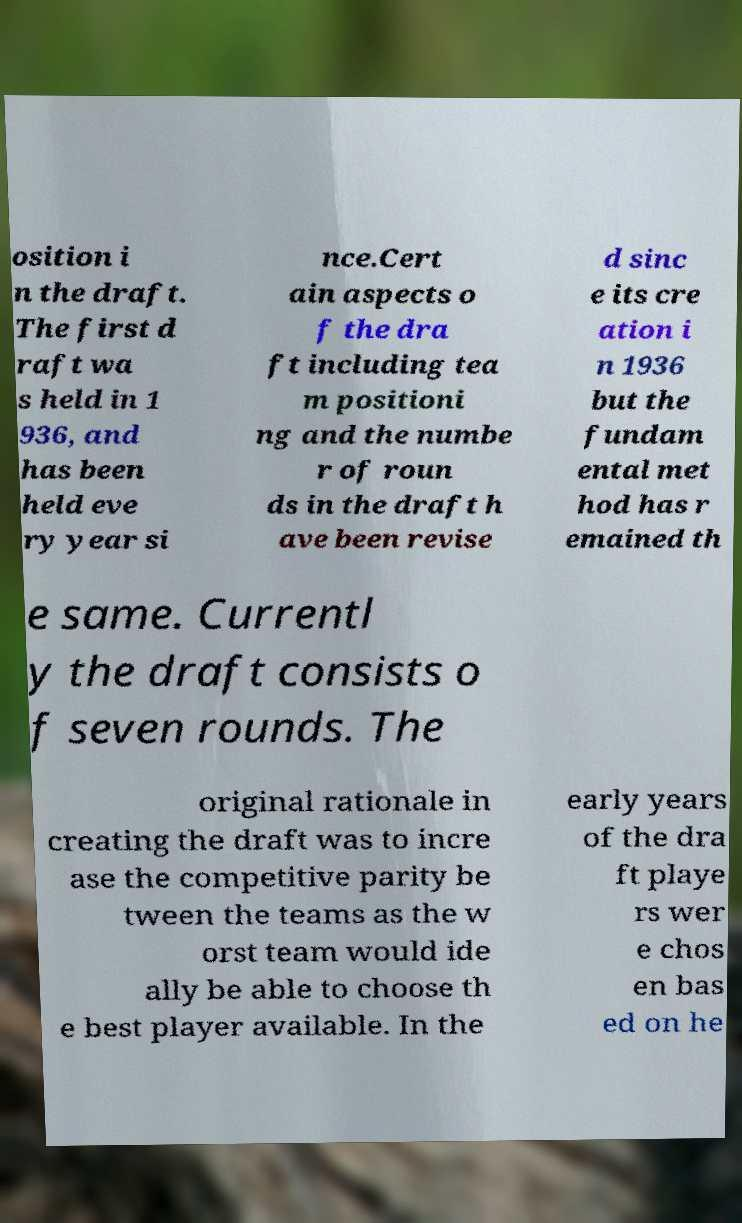Can you read and provide the text displayed in the image?This photo seems to have some interesting text. Can you extract and type it out for me? osition i n the draft. The first d raft wa s held in 1 936, and has been held eve ry year si nce.Cert ain aspects o f the dra ft including tea m positioni ng and the numbe r of roun ds in the draft h ave been revise d sinc e its cre ation i n 1936 but the fundam ental met hod has r emained th e same. Currentl y the draft consists o f seven rounds. The original rationale in creating the draft was to incre ase the competitive parity be tween the teams as the w orst team would ide ally be able to choose th e best player available. In the early years of the dra ft playe rs wer e chos en bas ed on he 